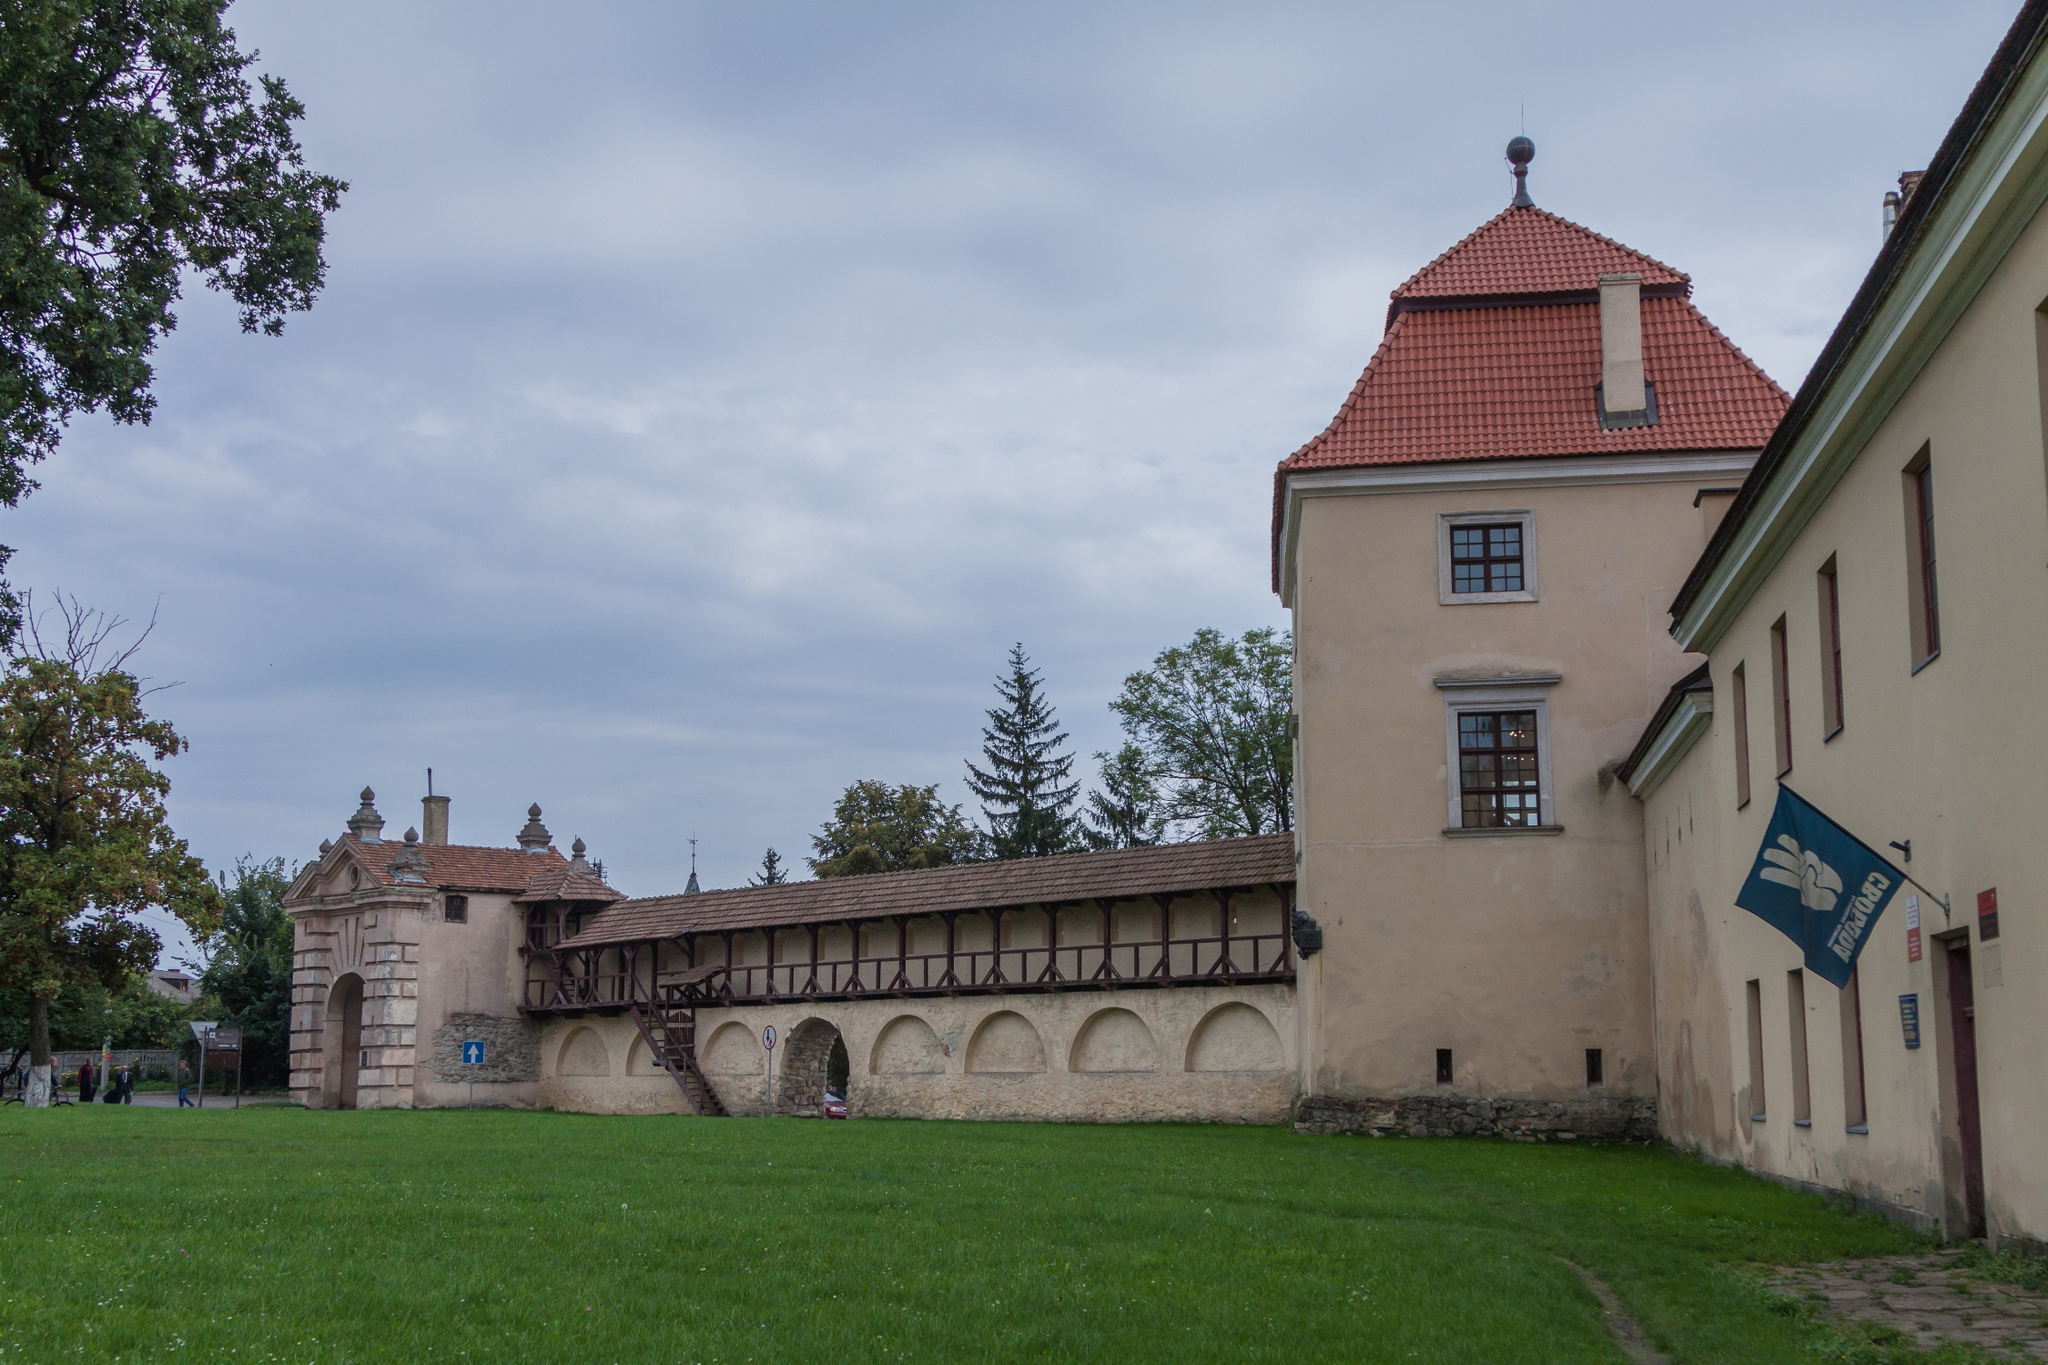How would you describe the atmosphere in this image to someone who cannot see it? The atmosphere in this image can be described as serene and tranquil. Imagine standing in a peaceful park surrounded by lush green grass and tall, leafy trees. The air is still and cool, with a soft overcast sky casting a gentle, muted light over the scene. The centerpiece is a grand historic building with a distinctive red-tiled roof and an elegant elevated walkway. This structure exudes a sense of timelessness and quiet dignity, as if it has stood for centuries, watching over the surrounding landscape. The environment feels calm, inviting, and steeped in history, evoking a sense of reflection and admiration for the bygone eras it represents. 